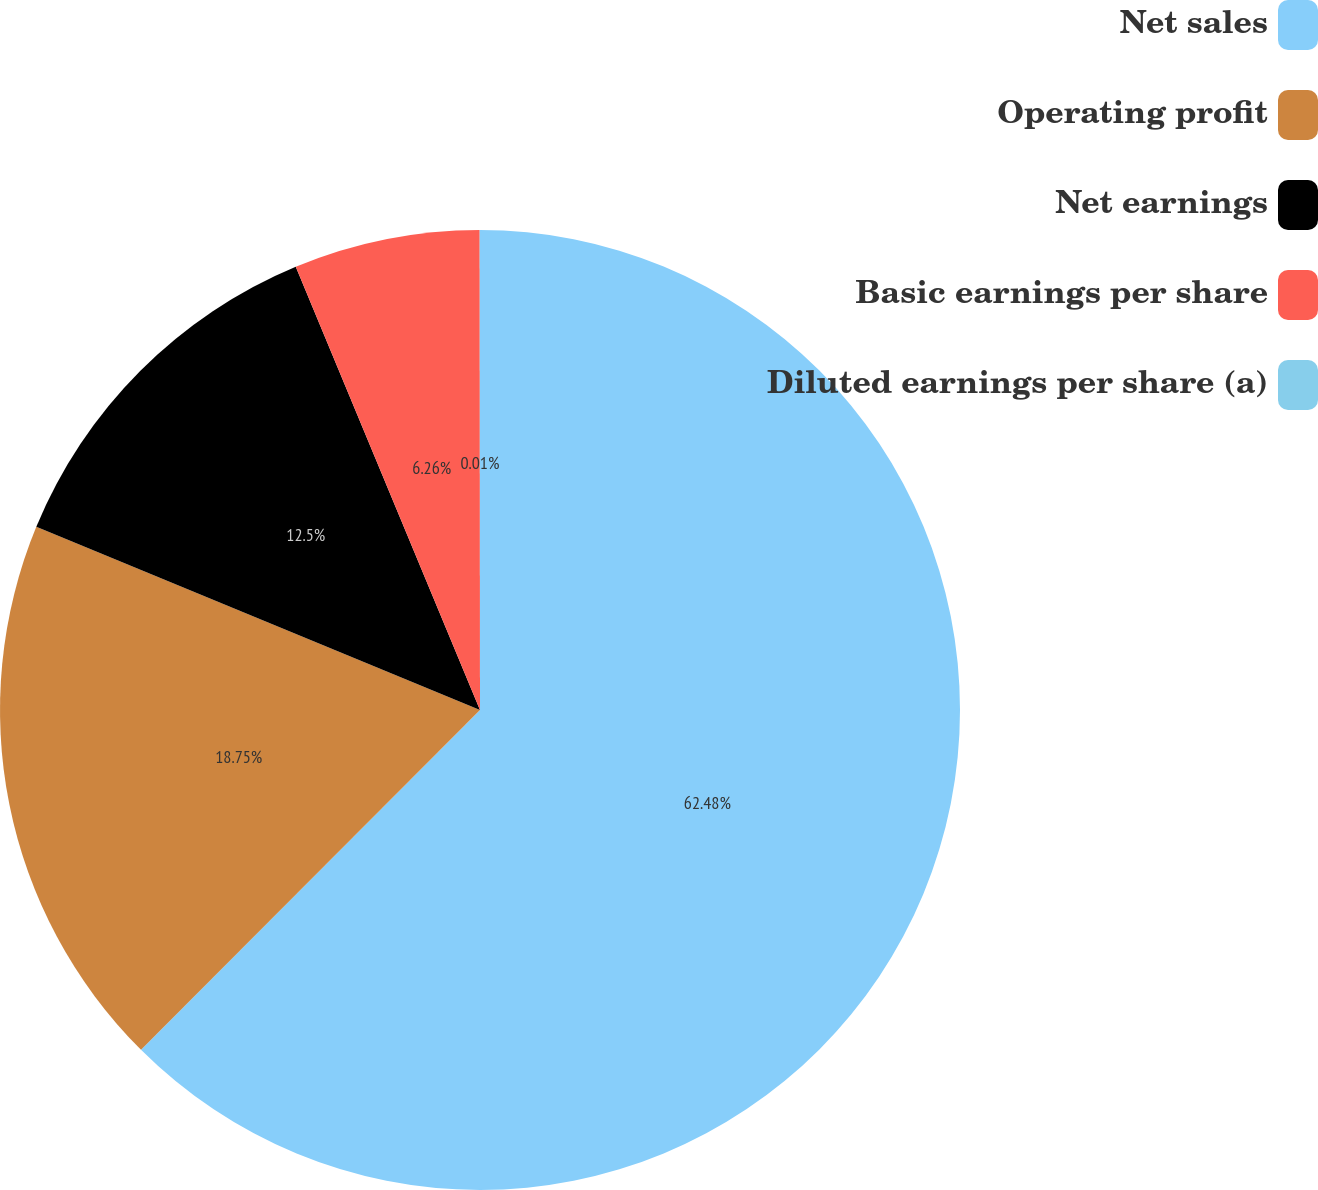<chart> <loc_0><loc_0><loc_500><loc_500><pie_chart><fcel>Net sales<fcel>Operating profit<fcel>Net earnings<fcel>Basic earnings per share<fcel>Diluted earnings per share (a)<nl><fcel>62.48%<fcel>18.75%<fcel>12.5%<fcel>6.26%<fcel>0.01%<nl></chart> 